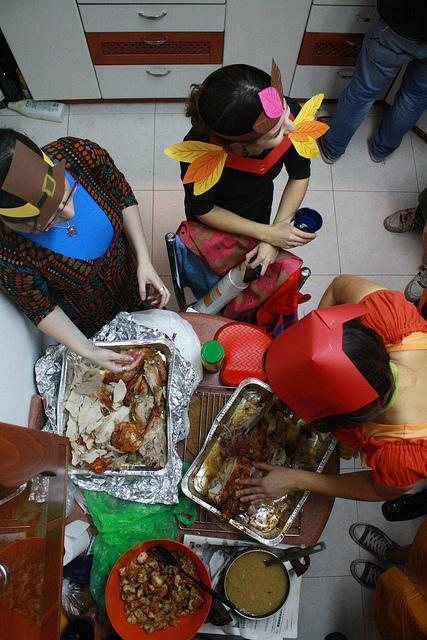What holiday do the people seem to be celebrating? thanksgiving 